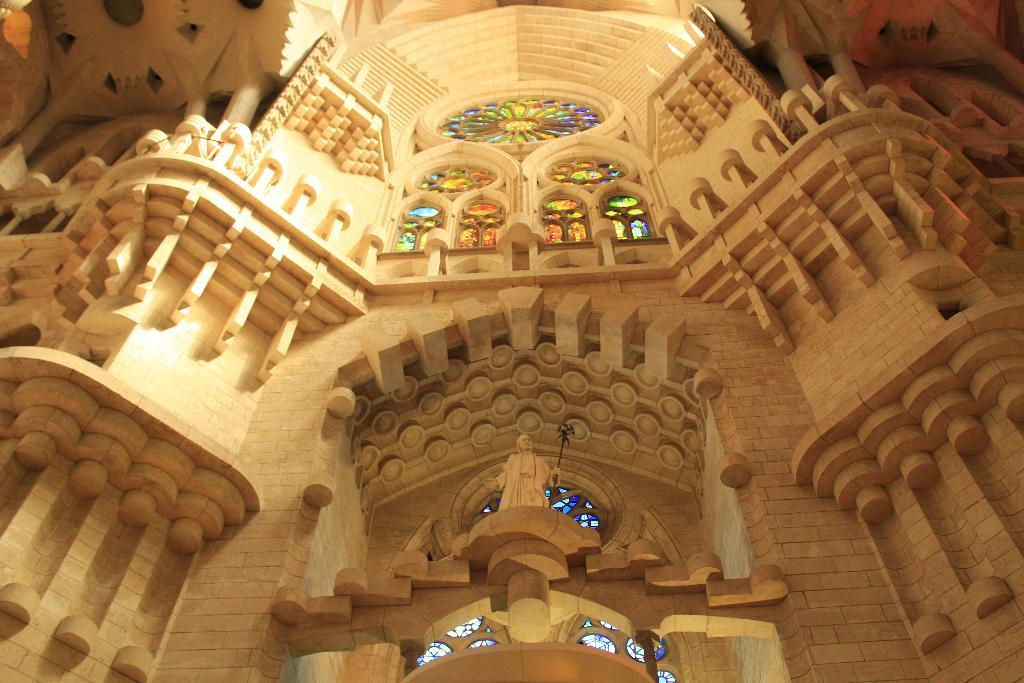What type of structure is visible in the image? There is a building in the image. What feature can be seen on the building? The building has windows. What additional object is present in the image? There is a statue in the image. What type of rhythm can be heard coming from the statue in the image? There is no indication of sound or rhythm in the image, as it features a building and a statue without any audible elements. 